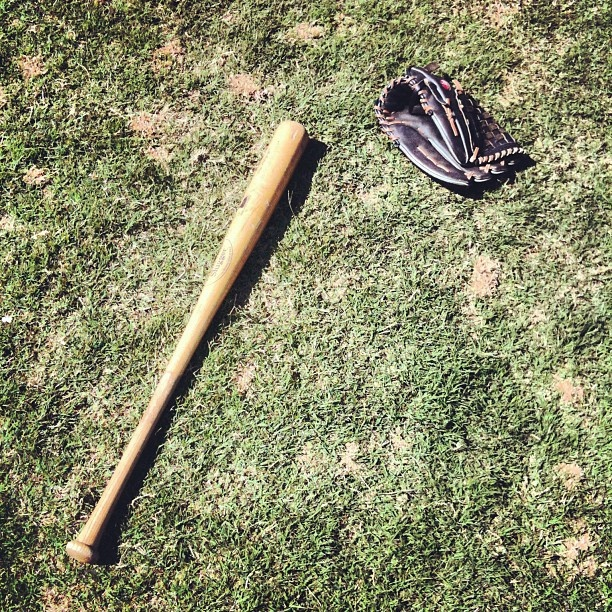Describe the objects in this image and their specific colors. I can see baseball bat in darkgreen, tan, lightyellow, and black tones and baseball glove in darkgreen, black, gray, lightgray, and darkgray tones in this image. 